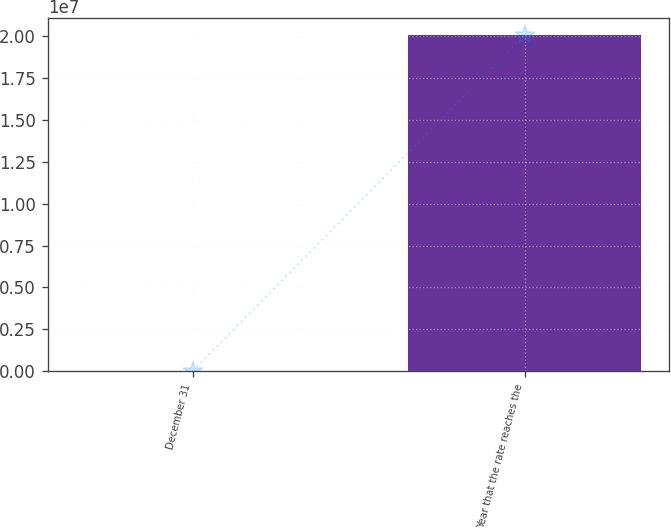<chart> <loc_0><loc_0><loc_500><loc_500><bar_chart><fcel>December 31<fcel>Year that the rate reaches the<nl><fcel>2007<fcel>2.0082e+07<nl></chart> 